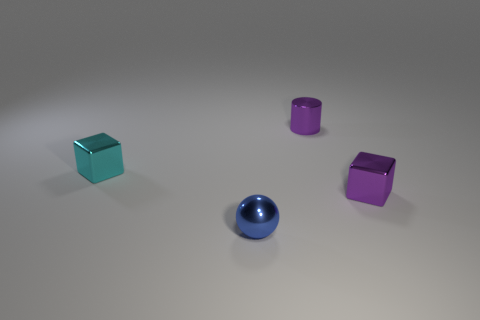Can you tell me what colors the objects in the image are? Certainly! The image features five objects, each with a distinct color: there's a green cube, a blue sphere, and three other cubes in shades of teal, purple, and magenta. 